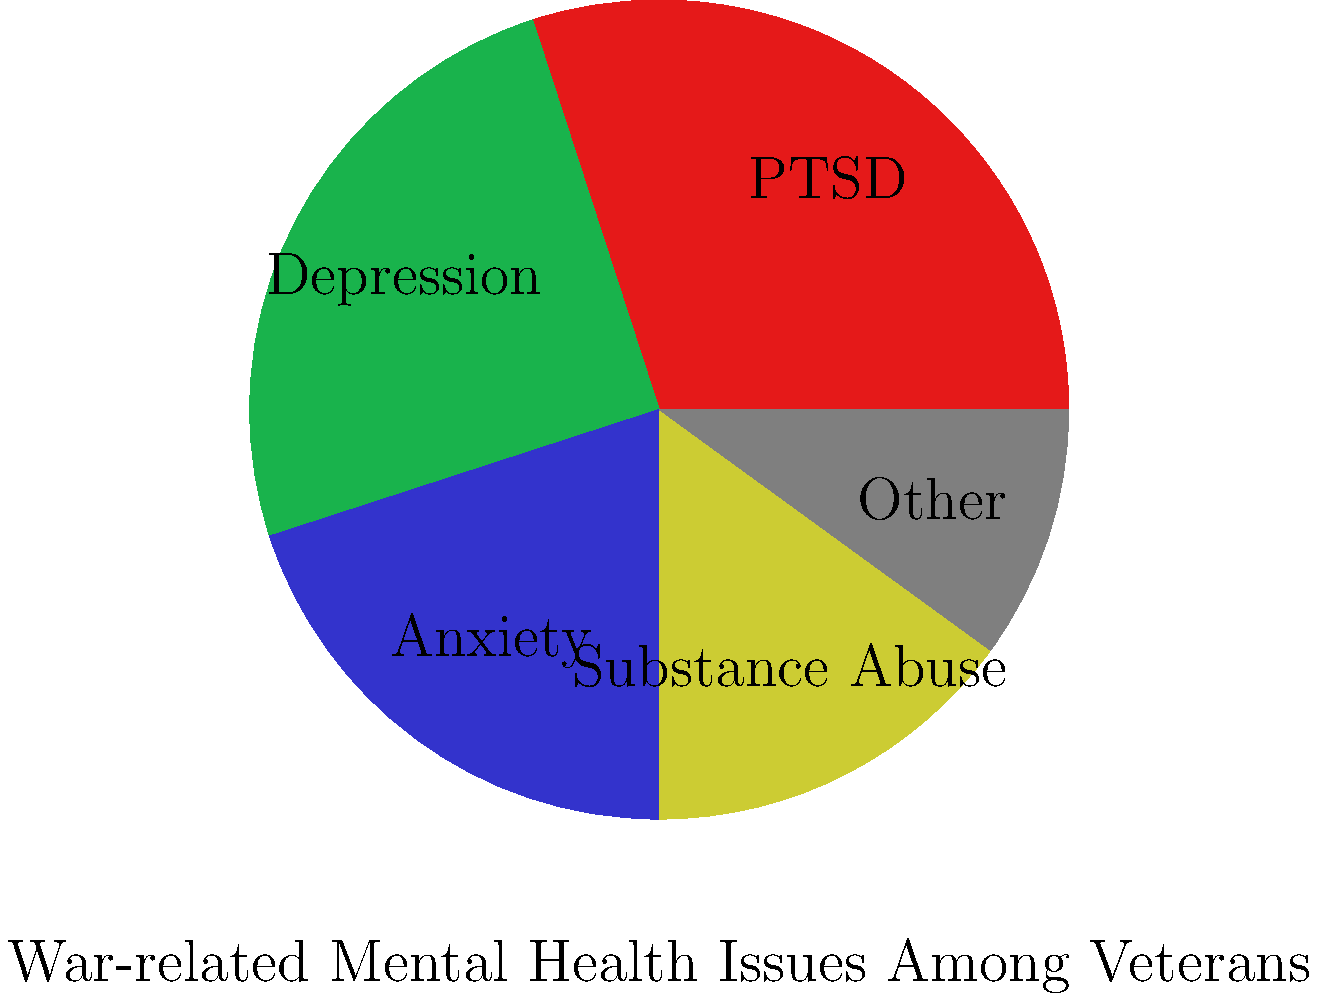Based on the pie chart depicting the distribution of war-related mental health issues among veterans, which mental health condition is most prevalent, and what percentage of veterans are affected by it? To answer this question, we need to analyze the pie chart and follow these steps:

1. Identify all mental health conditions shown in the chart:
   - PTSD (Post-Traumatic Stress Disorder)
   - Depression
   - Anxiety
   - Substance Abuse
   - Other

2. Determine which slice of the pie is the largest:
   The largest slice corresponds to PTSD.

3. Calculate the percentage represented by the PTSD slice:
   - The pie chart is divided into 5 sections.
   - The PTSD slice appears to cover about 30% of the total area.

4. Verify that PTSD has the highest percentage compared to other conditions:
   - Depression: approximately 25%
   - Anxiety: approximately 20%
   - Substance Abuse: approximately 15%
   - Other: approximately 10%

5. Conclude that PTSD is indeed the most prevalent condition, affecting 30% of veterans.

This analysis reveals the significant impact of PTSD on veterans' mental health, which is crucial information for historians studying the consequences of post-Yugoslav wars and the experiences of veterans.
Answer: PTSD, affecting 30% of veterans 